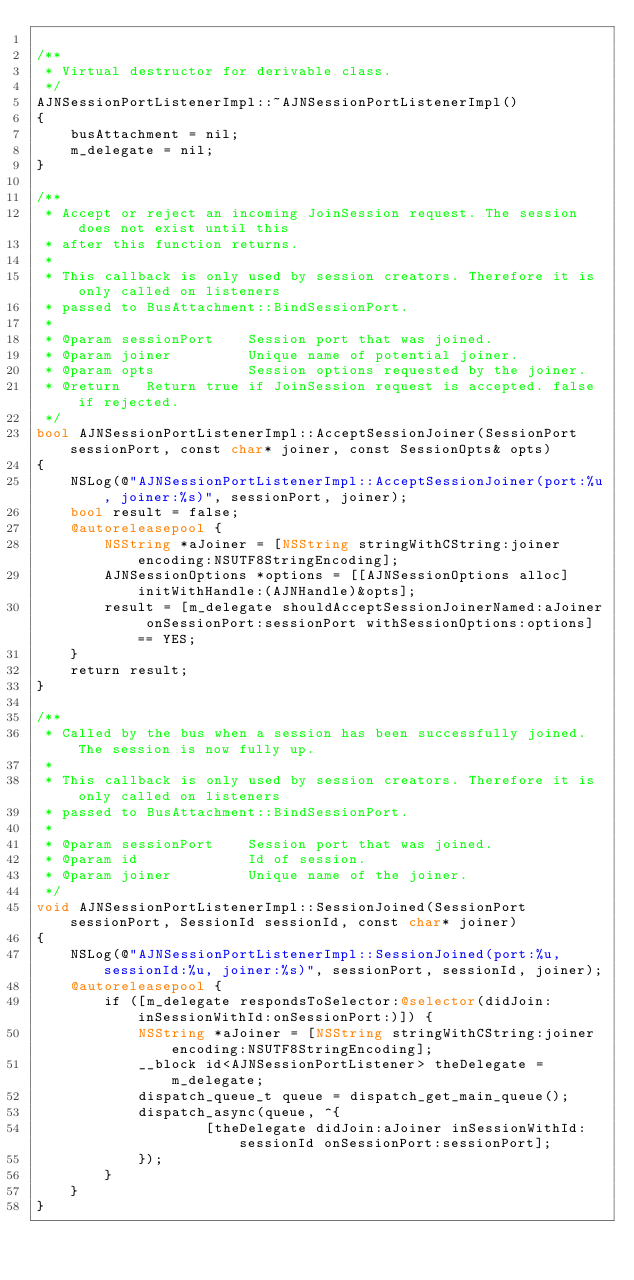Convert code to text. <code><loc_0><loc_0><loc_500><loc_500><_ObjectiveC_>
/**
 * Virtual destructor for derivable class.
 */
AJNSessionPortListenerImpl::~AJNSessionPortListenerImpl()
{
    busAttachment = nil;
    m_delegate = nil;
}

/**
 * Accept or reject an incoming JoinSession request. The session does not exist until this
 * after this function returns.
 *
 * This callback is only used by session creators. Therefore it is only called on listeners
 * passed to BusAttachment::BindSessionPort.
 *
 * @param sessionPort    Session port that was joined.
 * @param joiner         Unique name of potential joiner.
 * @param opts           Session options requested by the joiner.
 * @return   Return true if JoinSession request is accepted. false if rejected.
 */
bool AJNSessionPortListenerImpl::AcceptSessionJoiner(SessionPort sessionPort, const char* joiner, const SessionOpts& opts)
{
    NSLog(@"AJNSessionPortListenerImpl::AcceptSessionJoiner(port:%u, joiner:%s)", sessionPort, joiner);
    bool result = false;
    @autoreleasepool {
        NSString *aJoiner = [NSString stringWithCString:joiner encoding:NSUTF8StringEncoding];
        AJNSessionOptions *options = [[AJNSessionOptions alloc] initWithHandle:(AJNHandle)&opts];
        result = [m_delegate shouldAcceptSessionJoinerNamed:aJoiner onSessionPort:sessionPort withSessionOptions:options] == YES;
    }
    return result;
}

/**
 * Called by the bus when a session has been successfully joined. The session is now fully up.
 *
 * This callback is only used by session creators. Therefore it is only called on listeners
 * passed to BusAttachment::BindSessionPort.
 *
 * @param sessionPort    Session port that was joined.
 * @param id             Id of session.
 * @param joiner         Unique name of the joiner.
 */
void AJNSessionPortListenerImpl::SessionJoined(SessionPort sessionPort, SessionId sessionId, const char* joiner)
{
    NSLog(@"AJNSessionPortListenerImpl::SessionJoined(port:%u, sessionId:%u, joiner:%s)", sessionPort, sessionId, joiner);
    @autoreleasepool {
        if ([m_delegate respondsToSelector:@selector(didJoin:inSessionWithId:onSessionPort:)]) {
            NSString *aJoiner = [NSString stringWithCString:joiner encoding:NSUTF8StringEncoding];
            __block id<AJNSessionPortListener> theDelegate = m_delegate;
            dispatch_queue_t queue = dispatch_get_main_queue();
            dispatch_async(queue, ^{
                    [theDelegate didJoin:aJoiner inSessionWithId:sessionId onSessionPort:sessionPort];
            });
        }
    }
}
</code> 